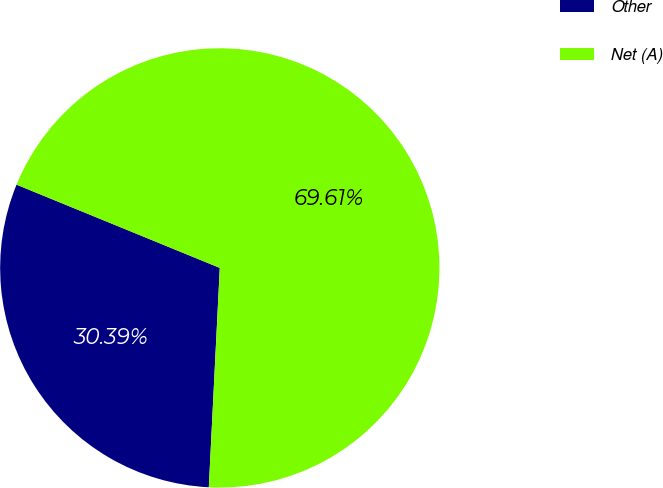Convert chart. <chart><loc_0><loc_0><loc_500><loc_500><pie_chart><fcel>Other<fcel>Net (A)<nl><fcel>30.39%<fcel>69.61%<nl></chart> 